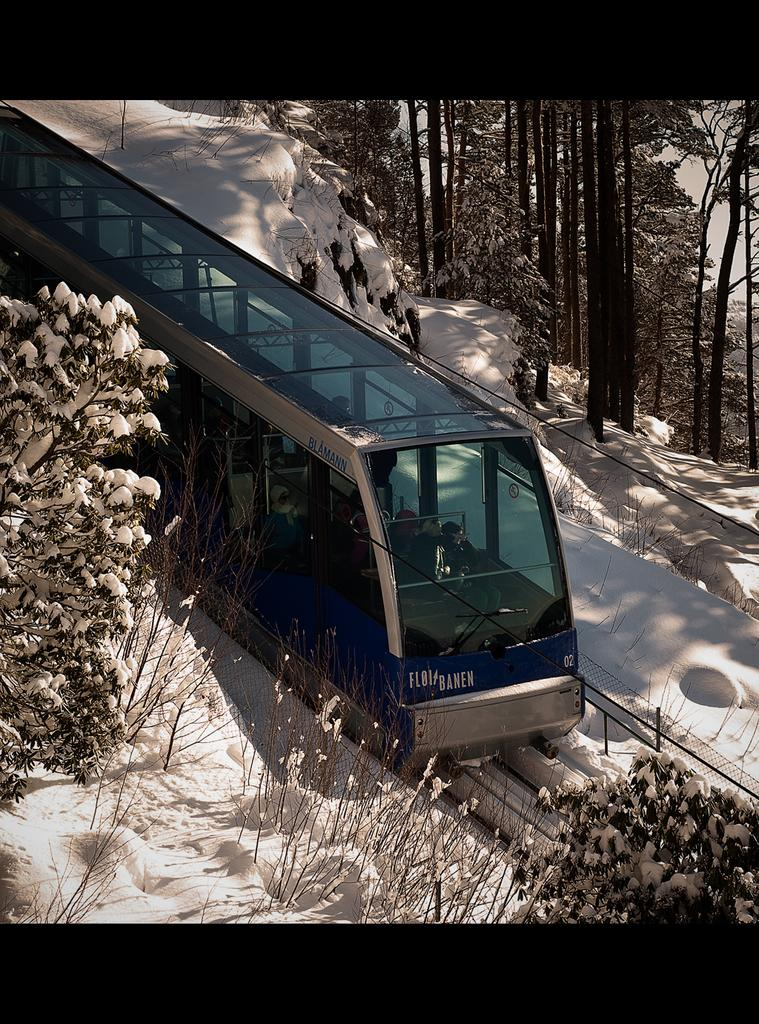What is the main subject of the image? The main subject of the image is a train. What is the train doing in the image? The train is moving on a track in the image. What is the weather like in the image? There is snow in the image, indicating a cold or wintery environment. What else can be seen in the image besides the train? There are trees in the image, and they are covered with snow. What type of rice can be seen in the image? There is no rice present in the image. How many children are visible in the image? There are no children visible in the image. 